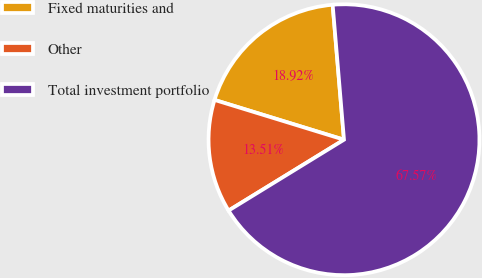<chart> <loc_0><loc_0><loc_500><loc_500><pie_chart><fcel>Fixed maturities and<fcel>Other<fcel>Total investment portfolio<nl><fcel>18.92%<fcel>13.51%<fcel>67.57%<nl></chart> 